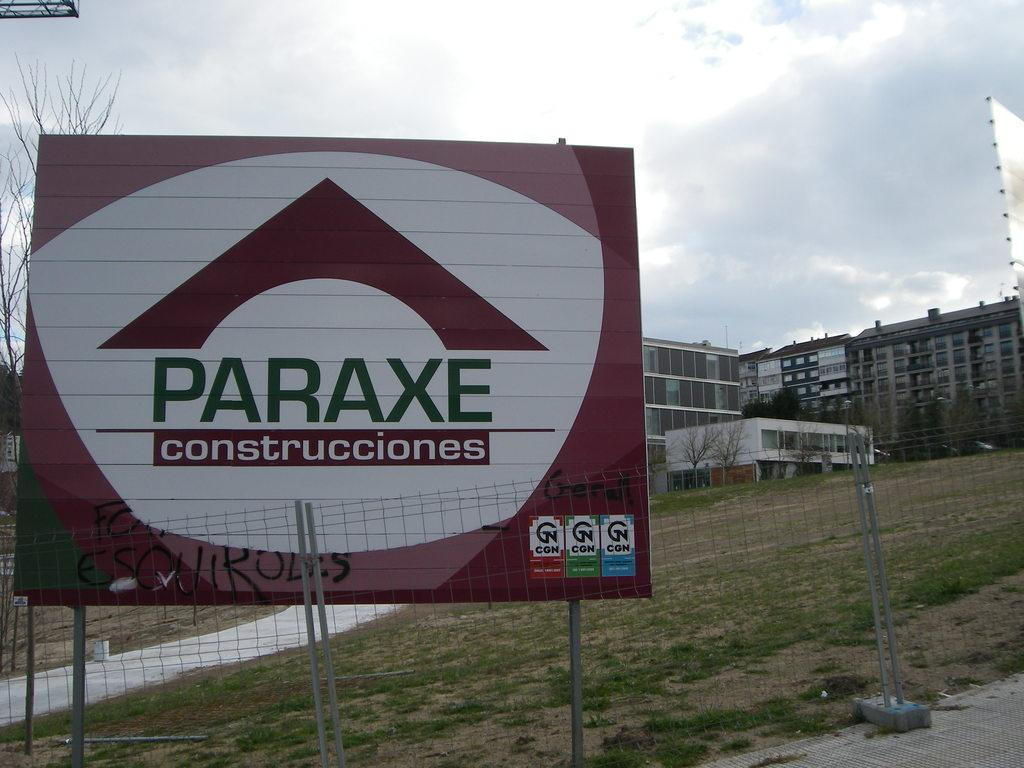<image>
Write a terse but informative summary of the picture. a Paraxe sogn having to do with construcciones. 